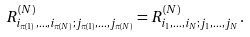<formula> <loc_0><loc_0><loc_500><loc_500>R ^ { ( N ) } _ { i _ { \pi ( 1 ) } , \dots , i _ { \pi ( N ) } ; j _ { \pi ( 1 ) } , \dots , j _ { \pi ( N ) } } = R ^ { ( N ) } _ { i _ { 1 } , \dots , i _ { N } ; j _ { 1 } , \dots , j _ { N } } \, .</formula> 